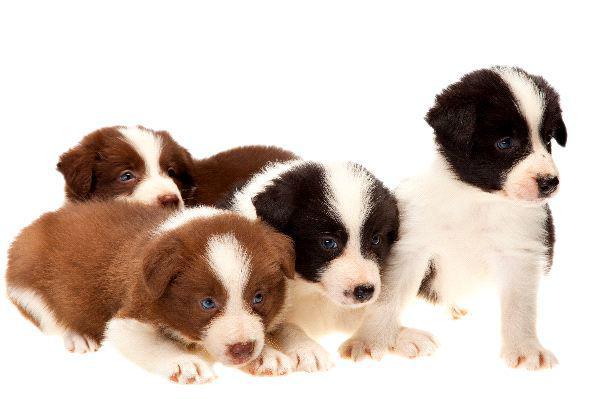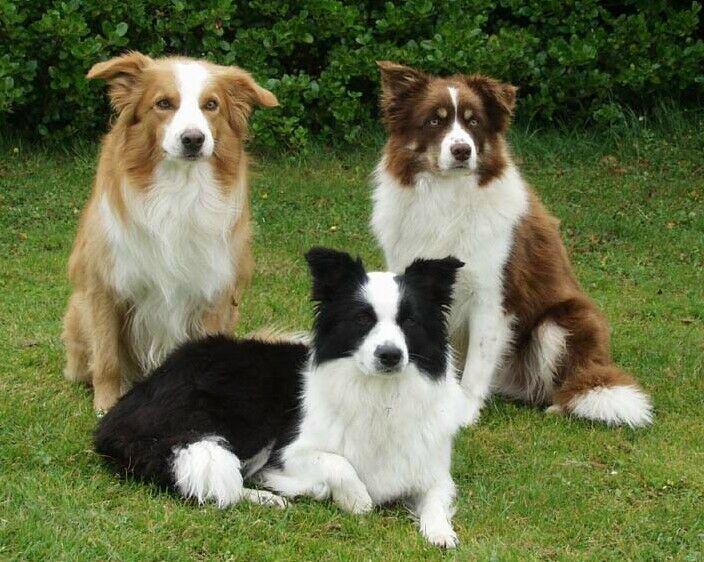The first image is the image on the left, the second image is the image on the right. Analyze the images presented: Is the assertion "Each image contains the same number of puppies, and all images have plain white backgrounds." valid? Answer yes or no. No. The first image is the image on the left, the second image is the image on the right. Considering the images on both sides, is "No more than four dogs can be seen." valid? Answer yes or no. No. 